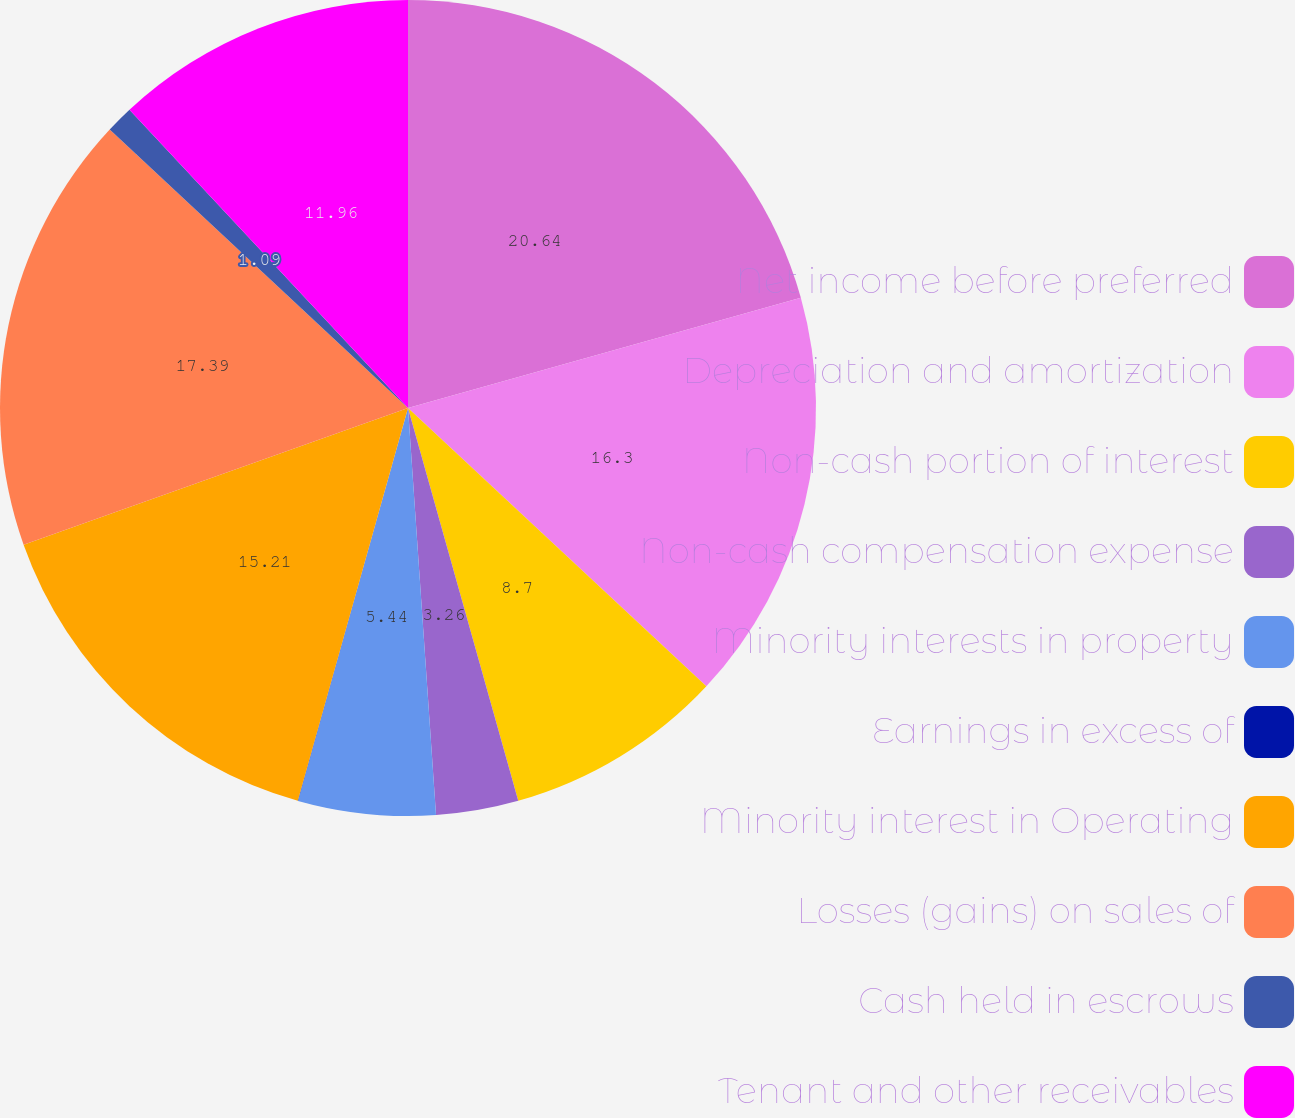Convert chart to OTSL. <chart><loc_0><loc_0><loc_500><loc_500><pie_chart><fcel>Net income before preferred<fcel>Depreciation and amortization<fcel>Non-cash portion of interest<fcel>Non-cash compensation expense<fcel>Minority interests in property<fcel>Earnings in excess of<fcel>Minority interest in Operating<fcel>Losses (gains) on sales of<fcel>Cash held in escrows<fcel>Tenant and other receivables<nl><fcel>20.65%<fcel>16.3%<fcel>8.7%<fcel>3.26%<fcel>5.44%<fcel>0.01%<fcel>15.21%<fcel>17.39%<fcel>1.09%<fcel>11.96%<nl></chart> 